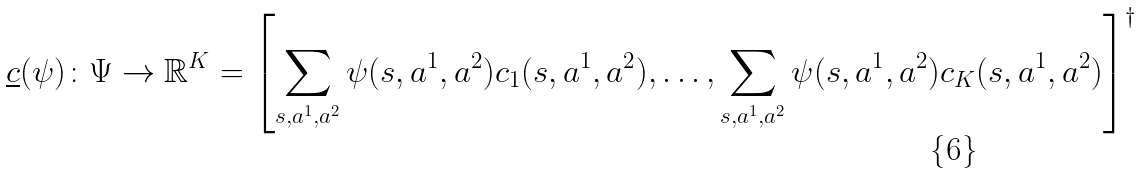<formula> <loc_0><loc_0><loc_500><loc_500>\underline { c } ( \psi ) \colon \Psi \rightarrow \mathbb { R } ^ { K } = \left [ \sum _ { s , a ^ { 1 } , a ^ { 2 } } \psi ( s , a ^ { 1 } , a ^ { 2 } ) c _ { 1 } ( s , a ^ { 1 } , a ^ { 2 } ) , \dots , \sum _ { s , a ^ { 1 } , a ^ { 2 } } \psi ( s , a ^ { 1 } , a ^ { 2 } ) c _ { K } ( s , a ^ { 1 } , a ^ { 2 } ) \right ] ^ { \dagger }</formula> 